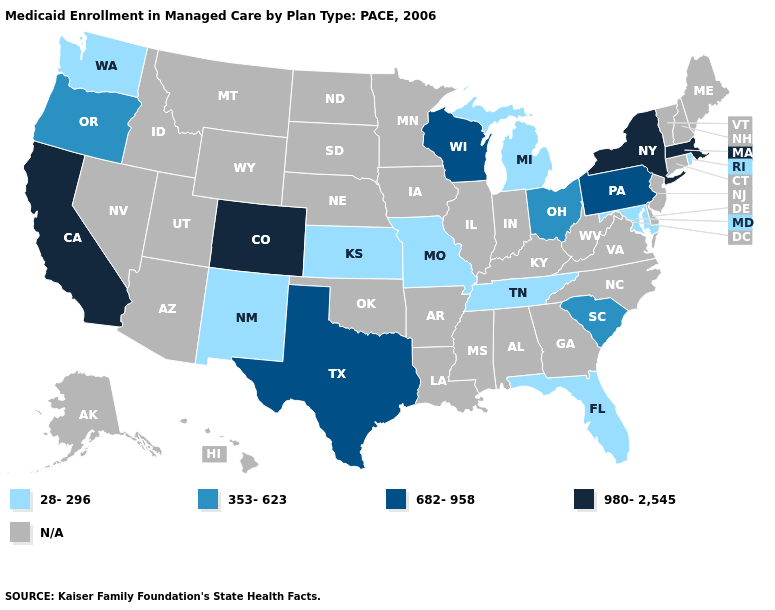What is the value of Arkansas?
Give a very brief answer. N/A. What is the value of Wyoming?
Be succinct. N/A. Name the states that have a value in the range 682-958?
Keep it brief. Pennsylvania, Texas, Wisconsin. What is the highest value in states that border Kentucky?
Concise answer only. 353-623. Name the states that have a value in the range 682-958?
Answer briefly. Pennsylvania, Texas, Wisconsin. What is the value of North Carolina?
Short answer required. N/A. What is the value of Florida?
Concise answer only. 28-296. Which states have the lowest value in the South?
Give a very brief answer. Florida, Maryland, Tennessee. Name the states that have a value in the range 682-958?
Keep it brief. Pennsylvania, Texas, Wisconsin. What is the value of Hawaii?
Keep it brief. N/A. What is the value of California?
Write a very short answer. 980-2,545. Name the states that have a value in the range N/A?
Quick response, please. Alabama, Alaska, Arizona, Arkansas, Connecticut, Delaware, Georgia, Hawaii, Idaho, Illinois, Indiana, Iowa, Kentucky, Louisiana, Maine, Minnesota, Mississippi, Montana, Nebraska, Nevada, New Hampshire, New Jersey, North Carolina, North Dakota, Oklahoma, South Dakota, Utah, Vermont, Virginia, West Virginia, Wyoming. What is the value of California?
Quick response, please. 980-2,545. 